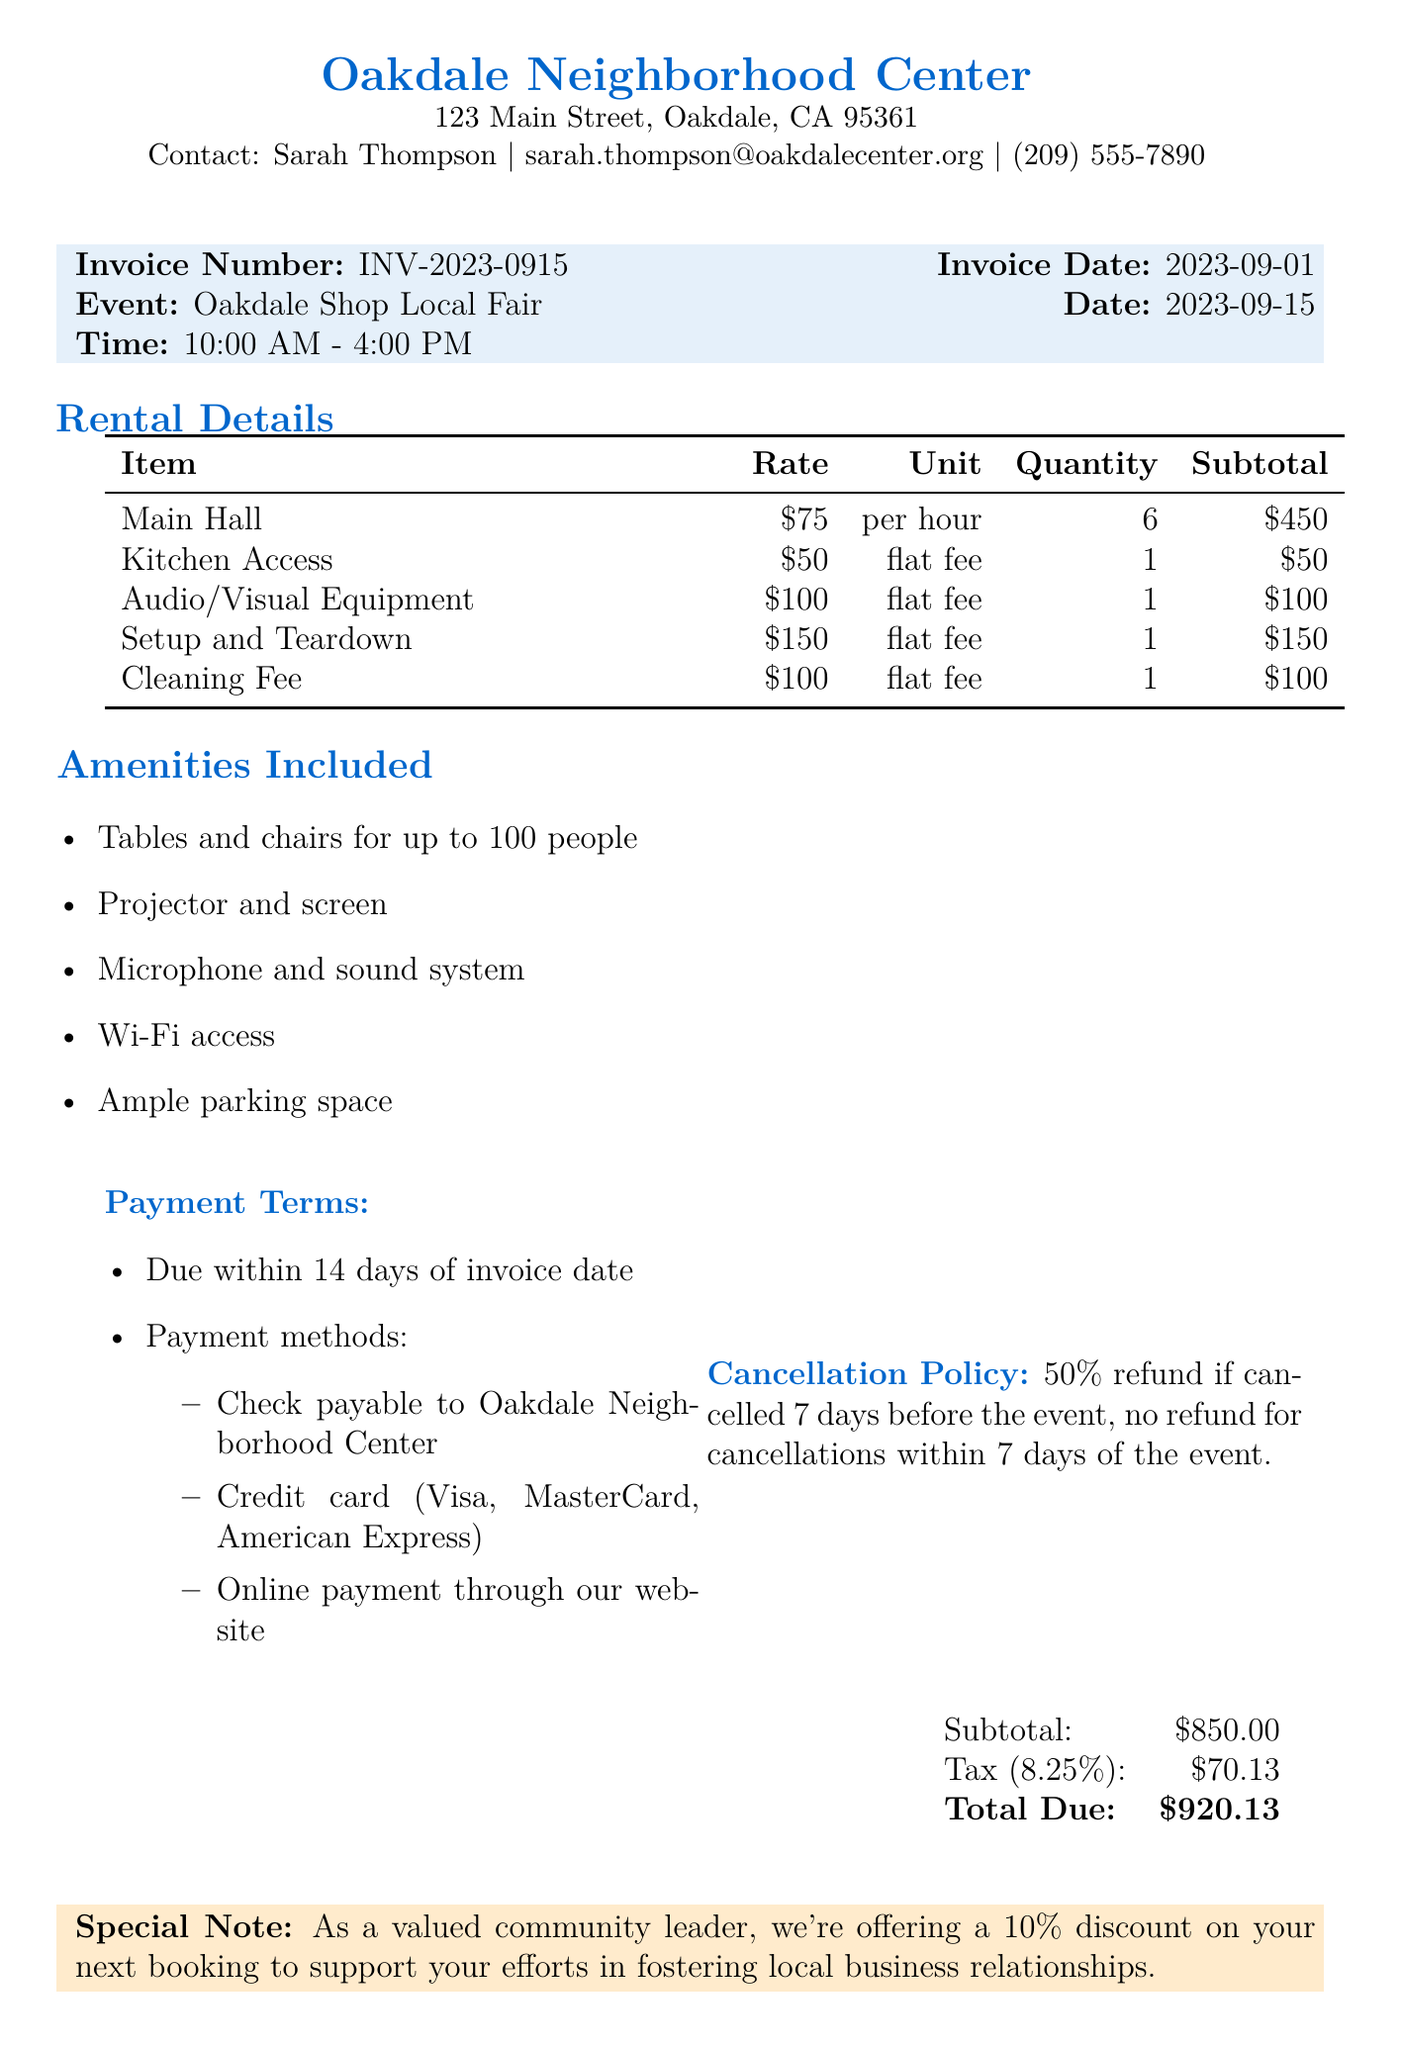What is the name of the community center? The community center name is located at the top of the document.
Answer: Oakdale Neighborhood Center Who is the contact person for the center? The contact person is mentioned near the community center information.
Answer: Sarah Thompson What is the event date? The event date is specified in the invoice details section.
Answer: 2023-09-15 What is the hourly rate for renting the Main Hall? The hourly rate is listed under rental details for the Main Hall item.
Answer: 75 What is the total amount due? The total amount due is shown in the financial summary at the bottom of the document.
Answer: 920.13 What amenities are included? Amenities are listed in a specific section in the document.
Answer: Tables and chairs for up to 100 people, Projector and screen, Microphone and sound system, Wi-Fi access, Ample parking space What is the cancellation policy? The cancellation policy is detailed in the document.
Answer: 50% refund if cancelled 7 days before the event, no refund for cancellations within 7 days of the event What discount is offered for the next booking? The discount offered is mentioned in the special notes section.
Answer: 10% What is the rental period for the Main Hall? The rental period is indicated in the rental details for the Main Hall.
Answer: 6 hours 